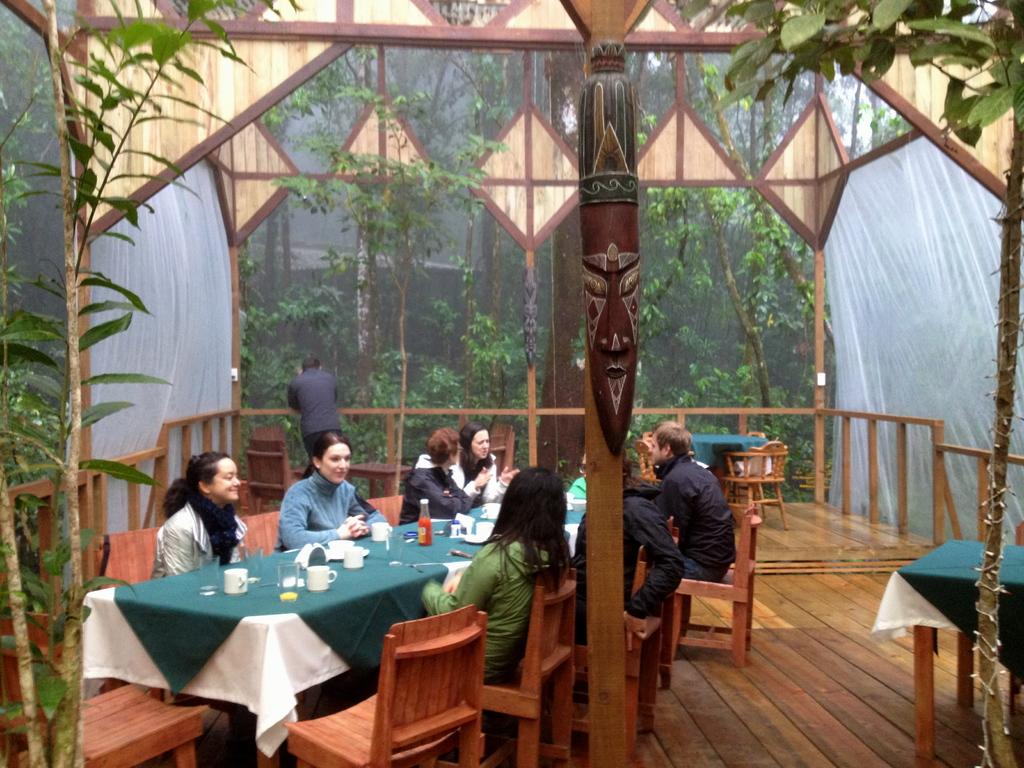How many people are in the image? There is a group of people in the image, but the exact number is not specified. What are the people doing in the image? The people are sitting in chairs in the image. What is on the table in front of the people? The table has a cup and a glass on it. What can be seen in the background of the image? There are trees around the people in the image. What type of cabbage is being served on the table in the image? There is no cabbage present on the table in the image; it has a cup and a glass. How many pies are visible on the table in the image? There are no pies visible on the table in the image; it has a cup and a glass. 